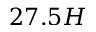<formula> <loc_0><loc_0><loc_500><loc_500>2 7 . 5 H</formula> 